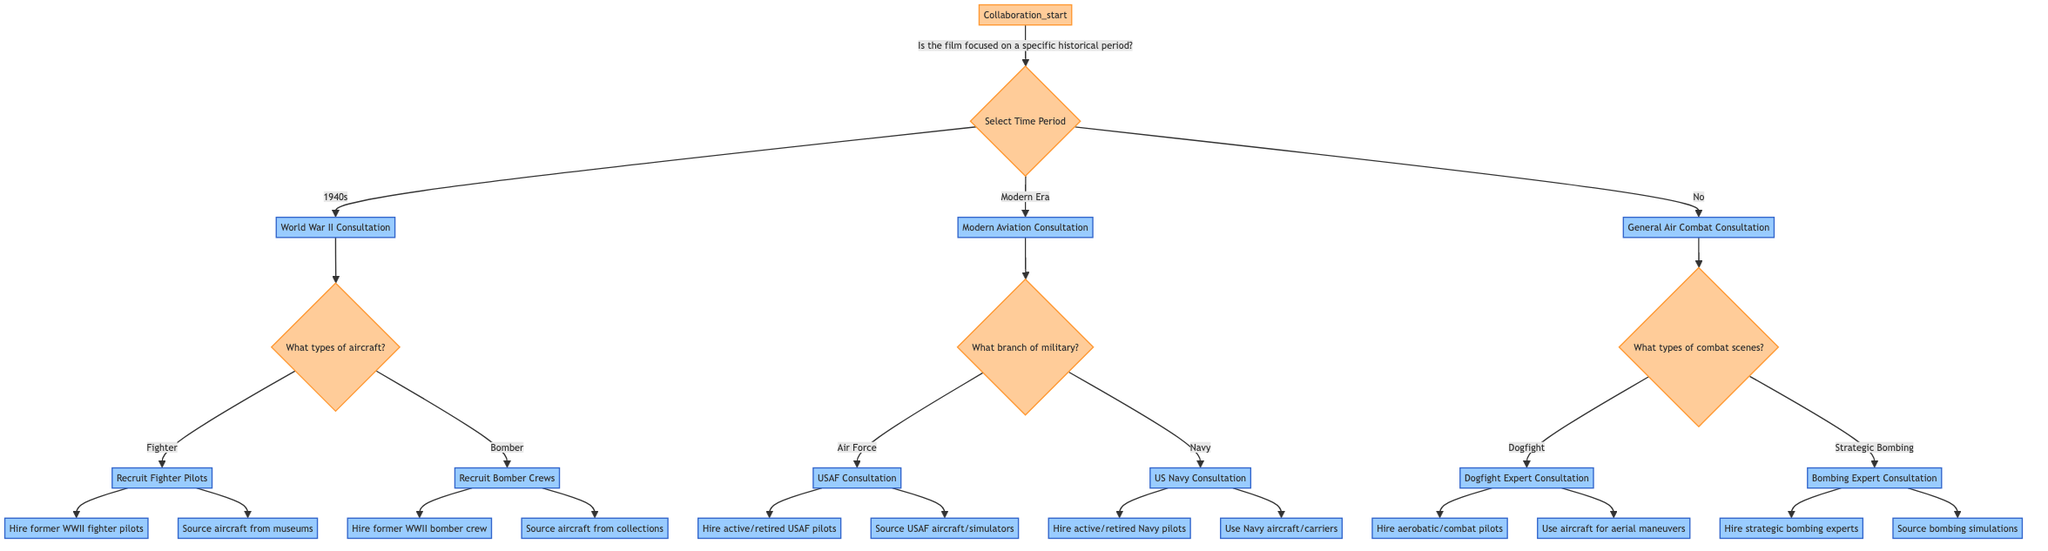What is the starting point of the decision tree? The starting point of the decision tree is labeled as "Collaboration_start," which represents the initial decision about engaging with aviation experts for the movie.
Answer: Collaboration_start What follows after selecting the "1940s" time period? After selecting the "1940s" time period, the next step is "World War II Consultation," indicating that the focus shifts to consulting World War II aviation experts and historians.
Answer: World War II Consultation How many types of aircraft options are there when focusing on the 1940s? There are two types of aircraft options when focusing on the 1940s: "Fighter" and "Bomber," which appear as distinct pathways in the diagram under the "What types of aircraft will be featured?" question.
Answer: Two What military branch do you consult if selecting the "Navy"? If selecting the "Navy," you consult with "US Navy Consultation," which represents engagement with US Navy aviators and expertise in aircraft carrier operations.
Answer: US Navy Consultation If the film is not focused on a specific historical period, what is the next step? If the film is not focused on a specific historical period, the next step is "General Air Combat Consultation," where you engage general aviation consultants and flight instructors.
Answer: General Air Combat Consultation What type of experts do you engage for "Dogfight"? For "Dogfight," you engage "Dogfight Expert Consultation," specifically hiring aerobatic pilots and air combat specialists to ensure the authenticity of the combat scenes.
Answer: Dogfight Expert Consultation If you choose "Modern Era," what are the two military branches to consider? The two military branches to consider when choosing "Modern Era" are "Air Force" and "Navy," which dictate the next steps in consulting respective military aviation experts.
Answer: Air Force and Navy What action is taken for recruiting pilots in the WWII "Fighter" segment? In the WWII "Fighter" segment, the action taken is "Recruit Fighter Pilots," which involves collaboration with vintage aircraft pilots and sourcing aircraft from museums and collectors.
Answer: Recruit Fighter Pilots What should be done if the film focuses on "Strategic Bombing"? If the film focuses on "Strategic Bombing," you should engage "Bombing Expert Consultation," consulting with strategic bombing experts and hiring those experienced in historic campaigns.
Answer: Bombing Expert Consultation 